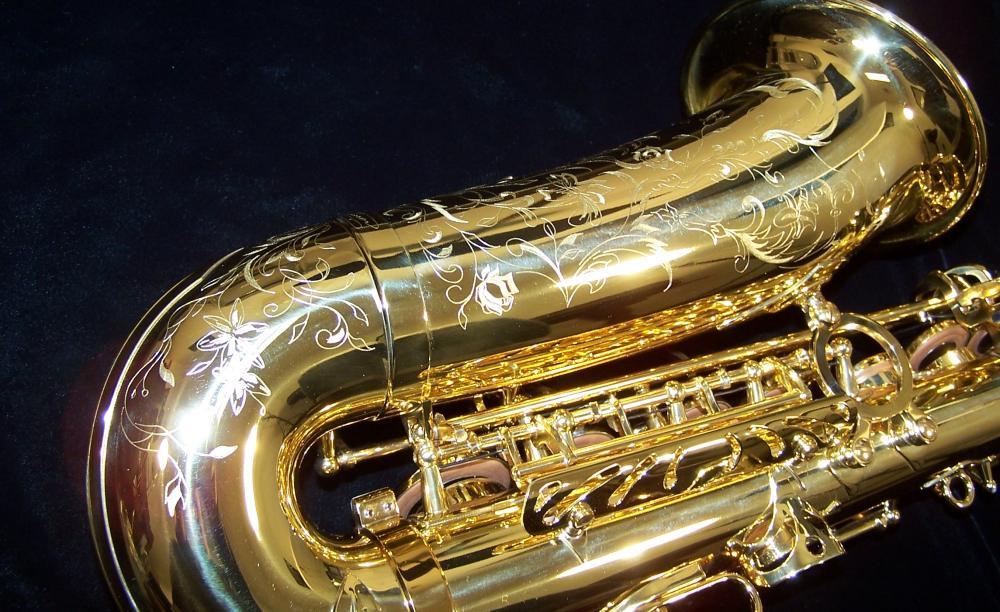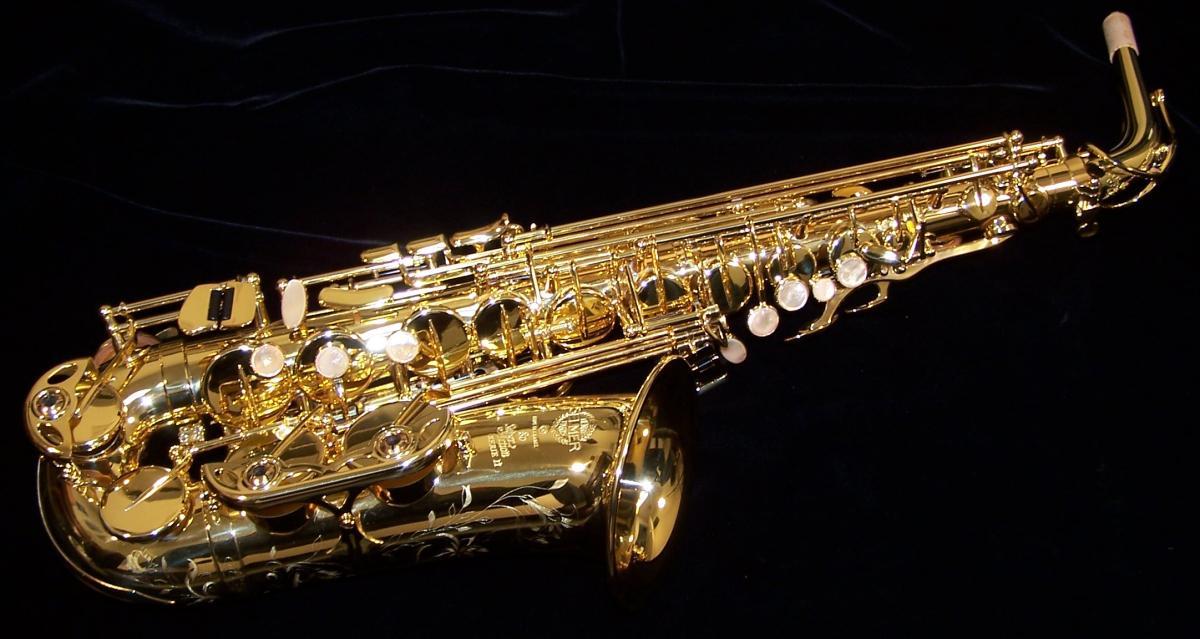The first image is the image on the left, the second image is the image on the right. For the images displayed, is the sentence "One of the saxophones has a floral engraving on the bell." factually correct? Answer yes or no. Yes. 